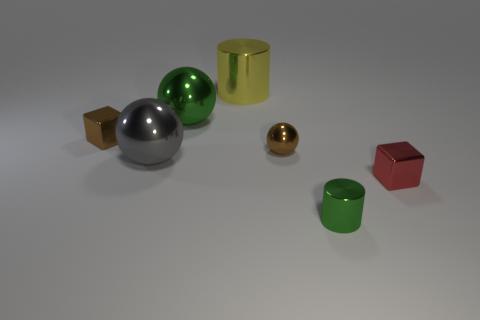How many other objects are the same material as the small red thing?
Your response must be concise. 6. Do the gray metallic thing and the tiny metallic object behind the brown shiny sphere have the same shape?
Provide a succinct answer. No. What is the shape of the gray thing that is the same material as the tiny brown sphere?
Provide a short and direct response. Sphere. Are there more cubes that are to the left of the yellow metal thing than big gray spheres that are behind the gray object?
Make the answer very short. Yes. What number of objects are either brown shiny cubes or small red objects?
Provide a succinct answer. 2. What number of other objects are the same color as the tiny metal cylinder?
Offer a terse response. 1. What is the shape of the yellow metallic object that is the same size as the green ball?
Your answer should be compact. Cylinder. What is the color of the shiny cylinder that is in front of the red cube?
Provide a succinct answer. Green. How many things are either green shiny objects behind the small brown metallic block or metal objects to the left of the green metal ball?
Keep it short and to the point. 3. Is the size of the green metallic cylinder the same as the brown shiny ball?
Keep it short and to the point. Yes. 